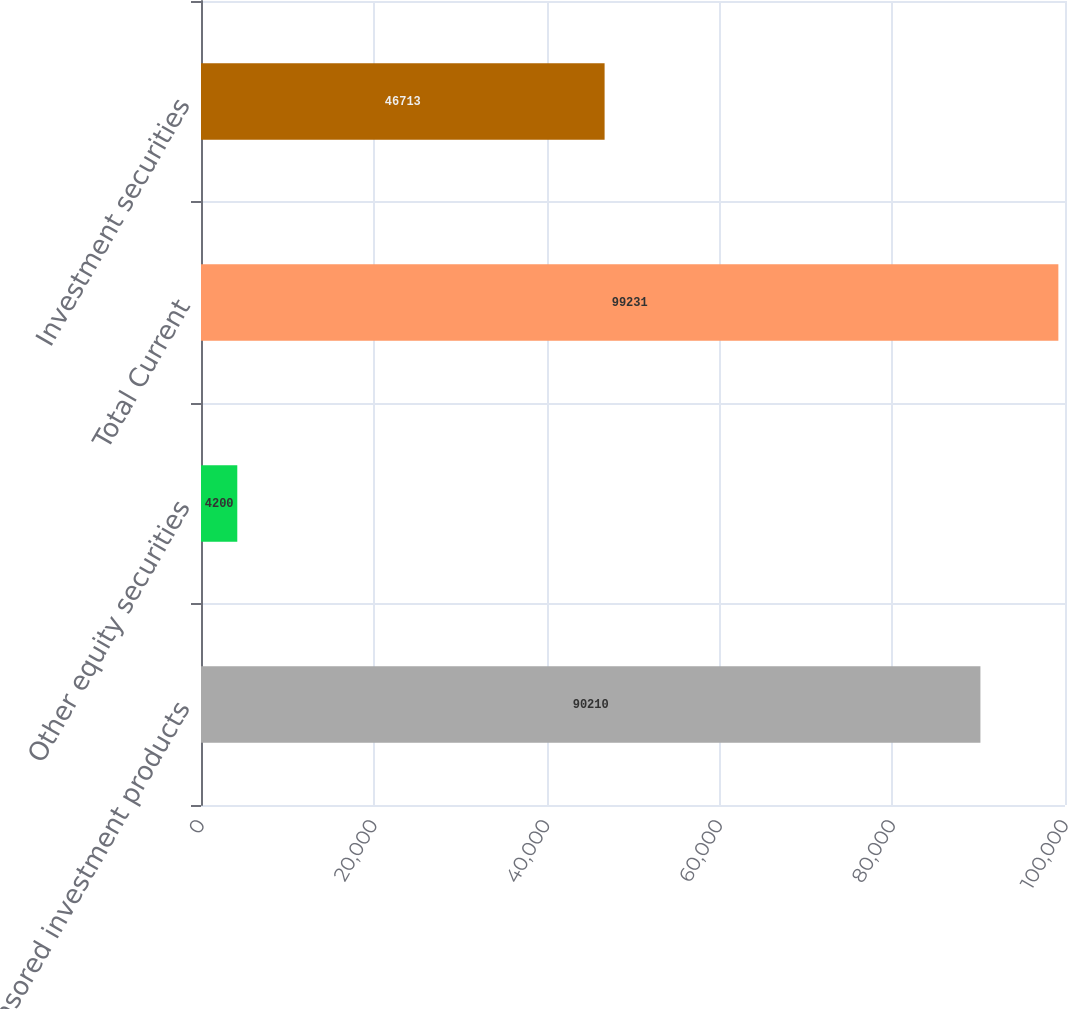Convert chart. <chart><loc_0><loc_0><loc_500><loc_500><bar_chart><fcel>Sponsored investment products<fcel>Other equity securities<fcel>Total Current<fcel>Investment securities<nl><fcel>90210<fcel>4200<fcel>99231<fcel>46713<nl></chart> 